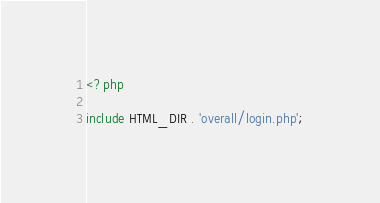<code> <loc_0><loc_0><loc_500><loc_500><_PHP_><?php

include HTML_DIR . 'overall/login.php';

</code> 